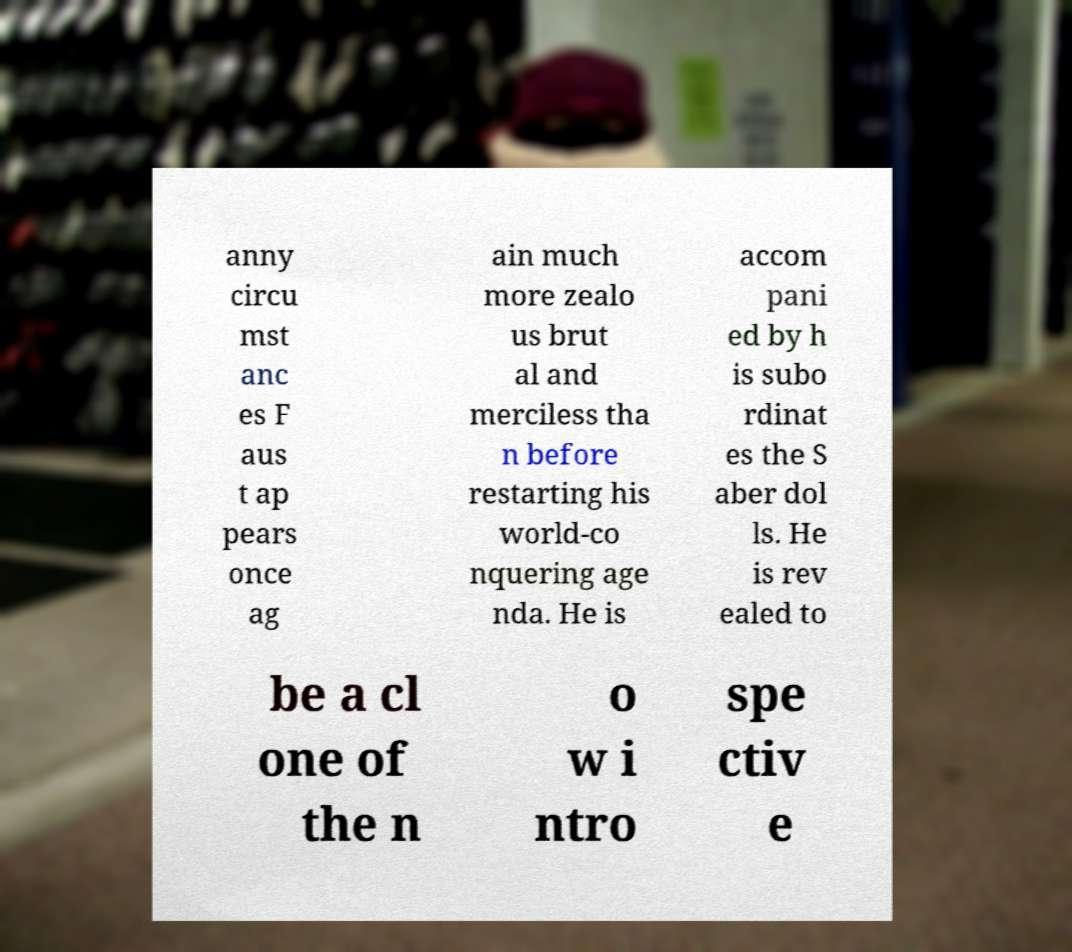Please read and relay the text visible in this image. What does it say? anny circu mst anc es F aus t ap pears once ag ain much more zealo us brut al and merciless tha n before restarting his world-co nquering age nda. He is accom pani ed by h is subo rdinat es the S aber dol ls. He is rev ealed to be a cl one of the n o w i ntro spe ctiv e 